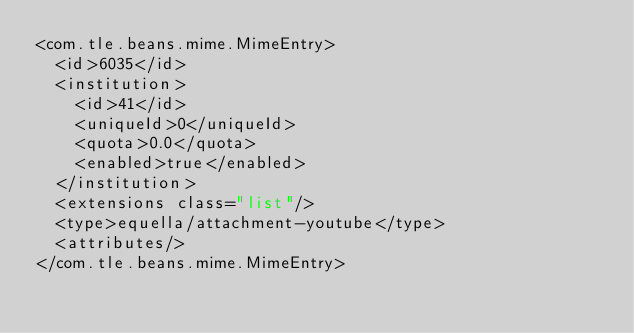<code> <loc_0><loc_0><loc_500><loc_500><_XML_><com.tle.beans.mime.MimeEntry>
  <id>6035</id>
  <institution>
    <id>41</id>
    <uniqueId>0</uniqueId>
    <quota>0.0</quota>
    <enabled>true</enabled>
  </institution>
  <extensions class="list"/>
  <type>equella/attachment-youtube</type>
  <attributes/>
</com.tle.beans.mime.MimeEntry></code> 